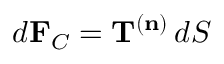Convert formula to latex. <formula><loc_0><loc_0><loc_500><loc_500>d F _ { C } = T ^ { ( n ) } \, d S</formula> 